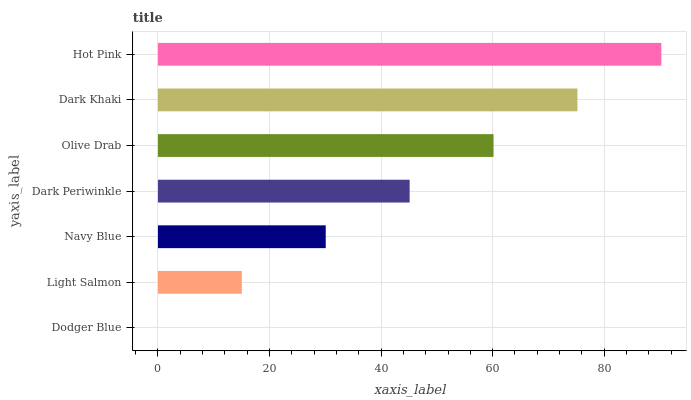Is Dodger Blue the minimum?
Answer yes or no. Yes. Is Hot Pink the maximum?
Answer yes or no. Yes. Is Light Salmon the minimum?
Answer yes or no. No. Is Light Salmon the maximum?
Answer yes or no. No. Is Light Salmon greater than Dodger Blue?
Answer yes or no. Yes. Is Dodger Blue less than Light Salmon?
Answer yes or no. Yes. Is Dodger Blue greater than Light Salmon?
Answer yes or no. No. Is Light Salmon less than Dodger Blue?
Answer yes or no. No. Is Dark Periwinkle the high median?
Answer yes or no. Yes. Is Dark Periwinkle the low median?
Answer yes or no. Yes. Is Light Salmon the high median?
Answer yes or no. No. Is Dark Khaki the low median?
Answer yes or no. No. 